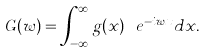<formula> <loc_0><loc_0><loc_500><loc_500>G ( w ) = \int _ { - \infty } ^ { \infty } g ( x ) \ e ^ { - i w x } d x .</formula> 